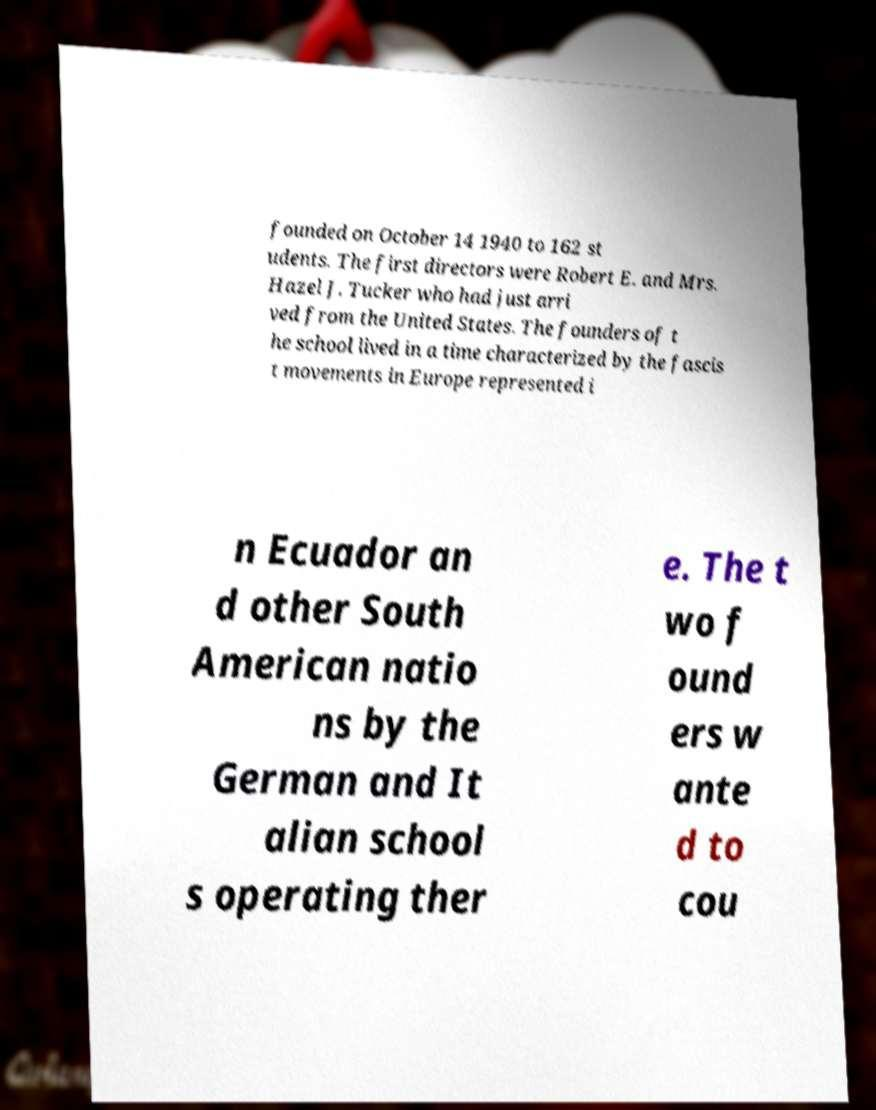Could you assist in decoding the text presented in this image and type it out clearly? founded on October 14 1940 to 162 st udents. The first directors were Robert E. and Mrs. Hazel J. Tucker who had just arri ved from the United States. The founders of t he school lived in a time characterized by the fascis t movements in Europe represented i n Ecuador an d other South American natio ns by the German and It alian school s operating ther e. The t wo f ound ers w ante d to cou 